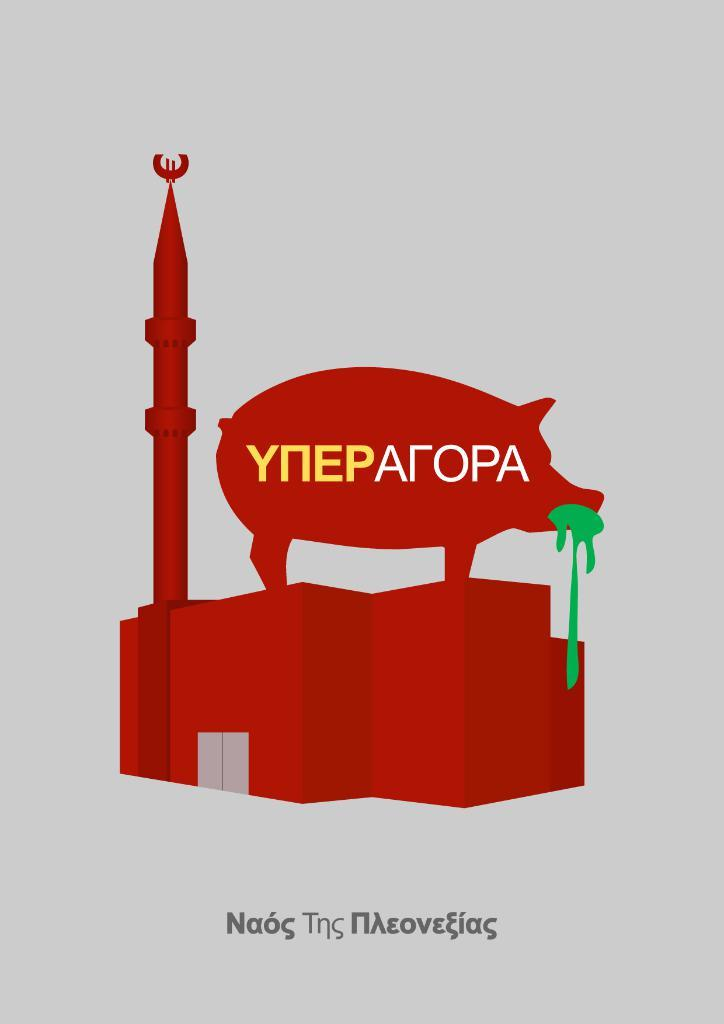<image>
Present a compact description of the photo's key features. A poster with a pig on it that says YNEPALOPA. 